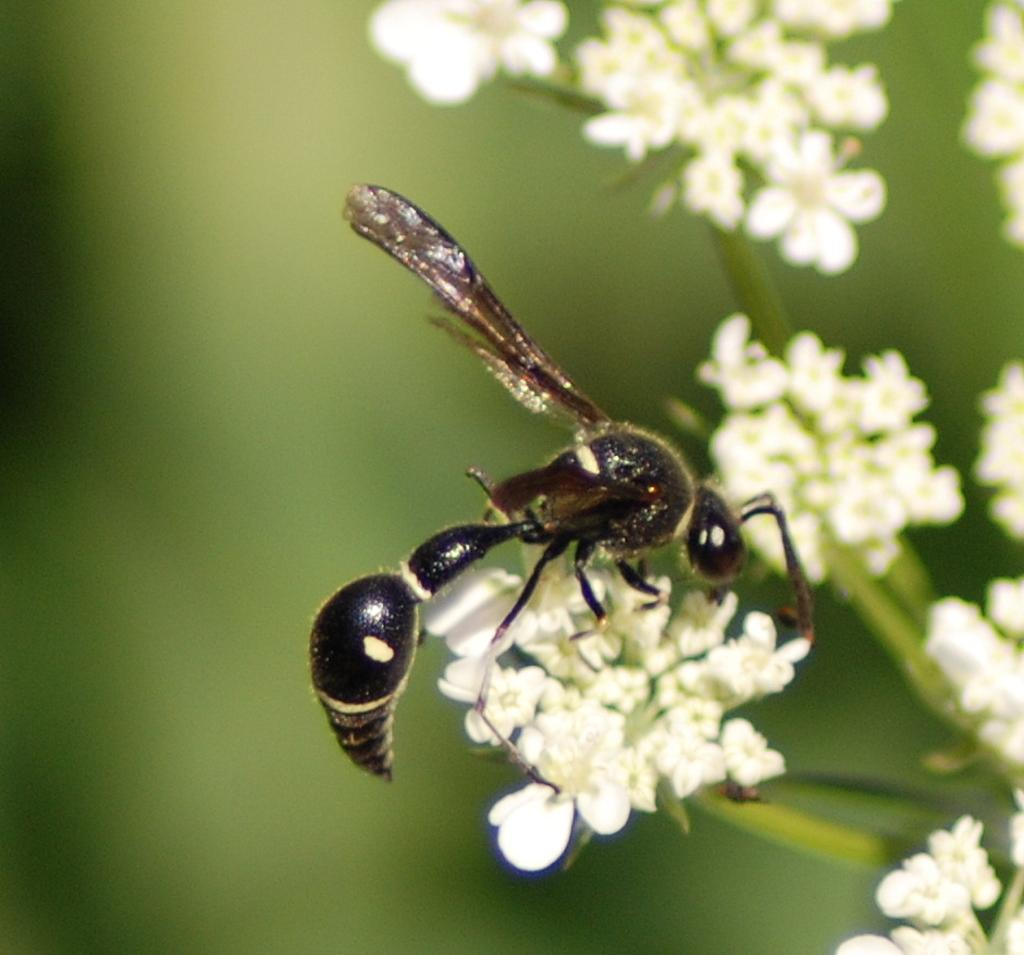What type of creature can be seen in the image? There is an insect in the image. Where is the insect located in the image? The insect is sitting on a flower. What type of wine is being served in the image? There is no wine present in the image; it features an insect sitting on a flower. How many pizzas can be seen in the image? There are no pizzas present in the image. 